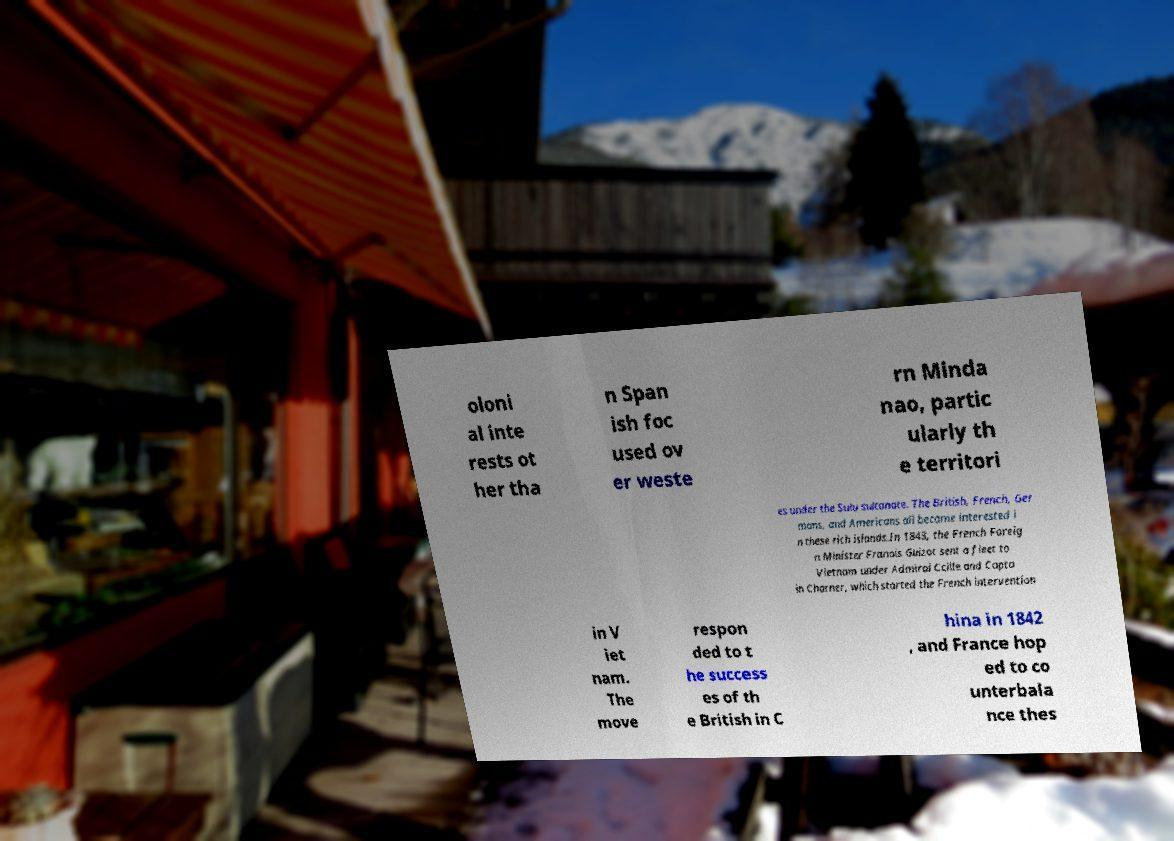Can you accurately transcribe the text from the provided image for me? oloni al inte rests ot her tha n Span ish foc used ov er weste rn Minda nao, partic ularly th e territori es under the Sulu sultanate. The British, French, Ger mans, and Americans all became interested i n these rich islands.In 1843, the French Foreig n Minister Franois Guizot sent a fleet to Vietnam under Admiral Ccille and Capta in Charner, which started the French intervention in V iet nam. The move respon ded to t he success es of th e British in C hina in 1842 , and France hop ed to co unterbala nce thes 